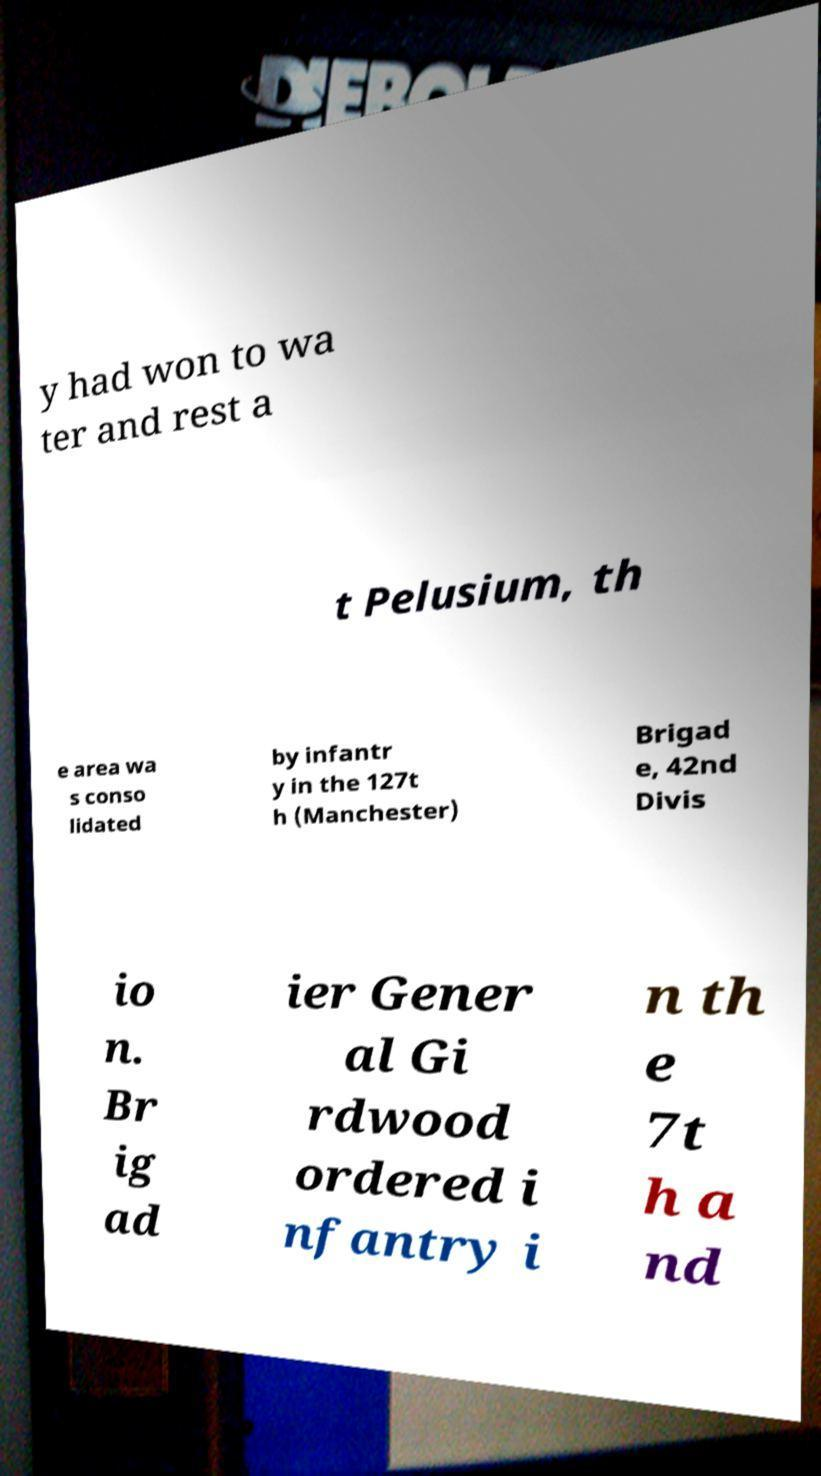Please identify and transcribe the text found in this image. y had won to wa ter and rest a t Pelusium, th e area wa s conso lidated by infantr y in the 127t h (Manchester) Brigad e, 42nd Divis io n. Br ig ad ier Gener al Gi rdwood ordered i nfantry i n th e 7t h a nd 